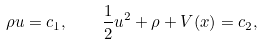<formula> <loc_0><loc_0><loc_500><loc_500>\rho u = c _ { 1 } , \quad \frac { 1 } { 2 } u ^ { 2 } + \rho + V ( x ) = c _ { 2 } ,</formula> 